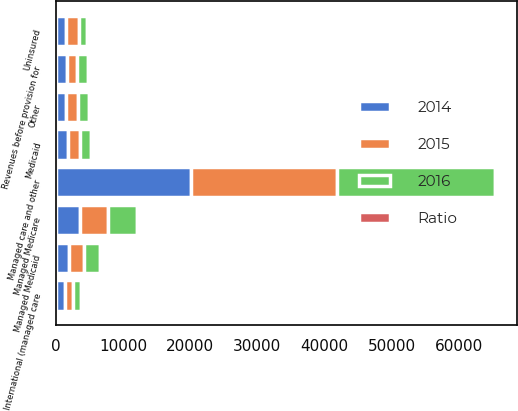Convert chart to OTSL. <chart><loc_0><loc_0><loc_500><loc_500><stacked_bar_chart><ecel><fcel>Managed Medicare<fcel>Medicaid<fcel>Managed Medicaid<fcel>Managed care and other<fcel>International (managed care<fcel>Uninsured<fcel>Other<fcel>Revenues before provision for<nl><fcel>2016<fcel>4355<fcel>1597<fcel>2478<fcel>23441<fcel>1195<fcel>1135<fcel>1651<fcel>1597<nl><fcel>Ratio<fcel>10.5<fcel>3.8<fcel>6<fcel>56.5<fcel>2.9<fcel>2.7<fcel>4<fcel>107.8<nl><fcel>2015<fcel>4133<fcel>1705<fcel>2234<fcel>21882<fcel>1295<fcel>1927<fcel>1761<fcel>1597<nl><fcel>2014<fcel>3614<fcel>1848<fcel>1923<fcel>20066<fcel>1311<fcel>1494<fcel>1477<fcel>1597<nl></chart> 